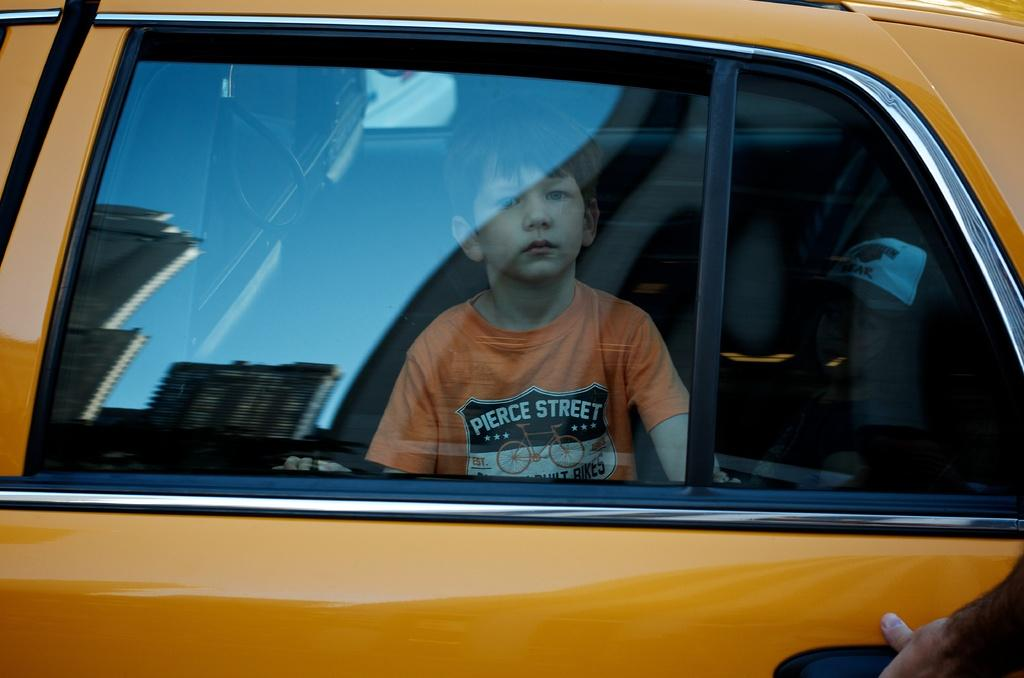<image>
Summarize the visual content of the image. A boy looking out a car window, wearing an orange shirt that says Pierce Street. 